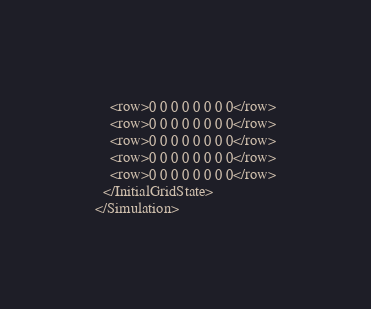Convert code to text. <code><loc_0><loc_0><loc_500><loc_500><_XML_>	<row>0 0 0 0 0 0 0 0</row>
	<row>0 0 0 0 0 0 0 0</row>
	<row>0 0 0 0 0 0 0 0</row>
	<row>0 0 0 0 0 0 0 0</row>
	<row>0 0 0 0 0 0 0 0</row>
  </InitialGridState>
</Simulation></code> 